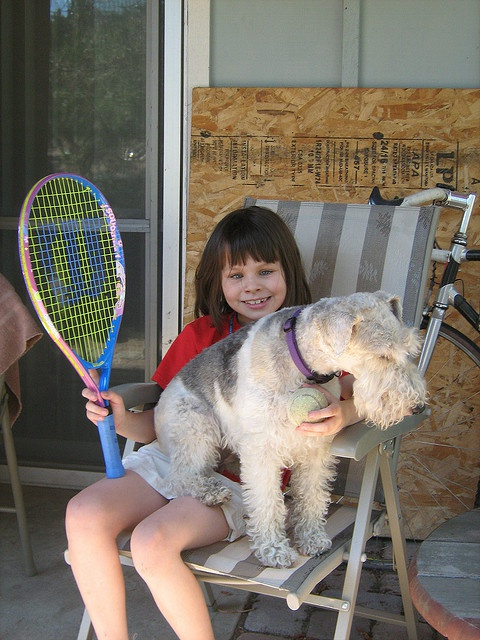Describe the objects in this image and their specific colors. I can see dog in black, darkgray, lightgray, tan, and gray tones, people in black, darkgray, gray, and lightpink tones, chair in black, gray, and darkgray tones, bicycle in black, gray, and maroon tones, and tennis racket in black, gray, and lightgreen tones in this image. 